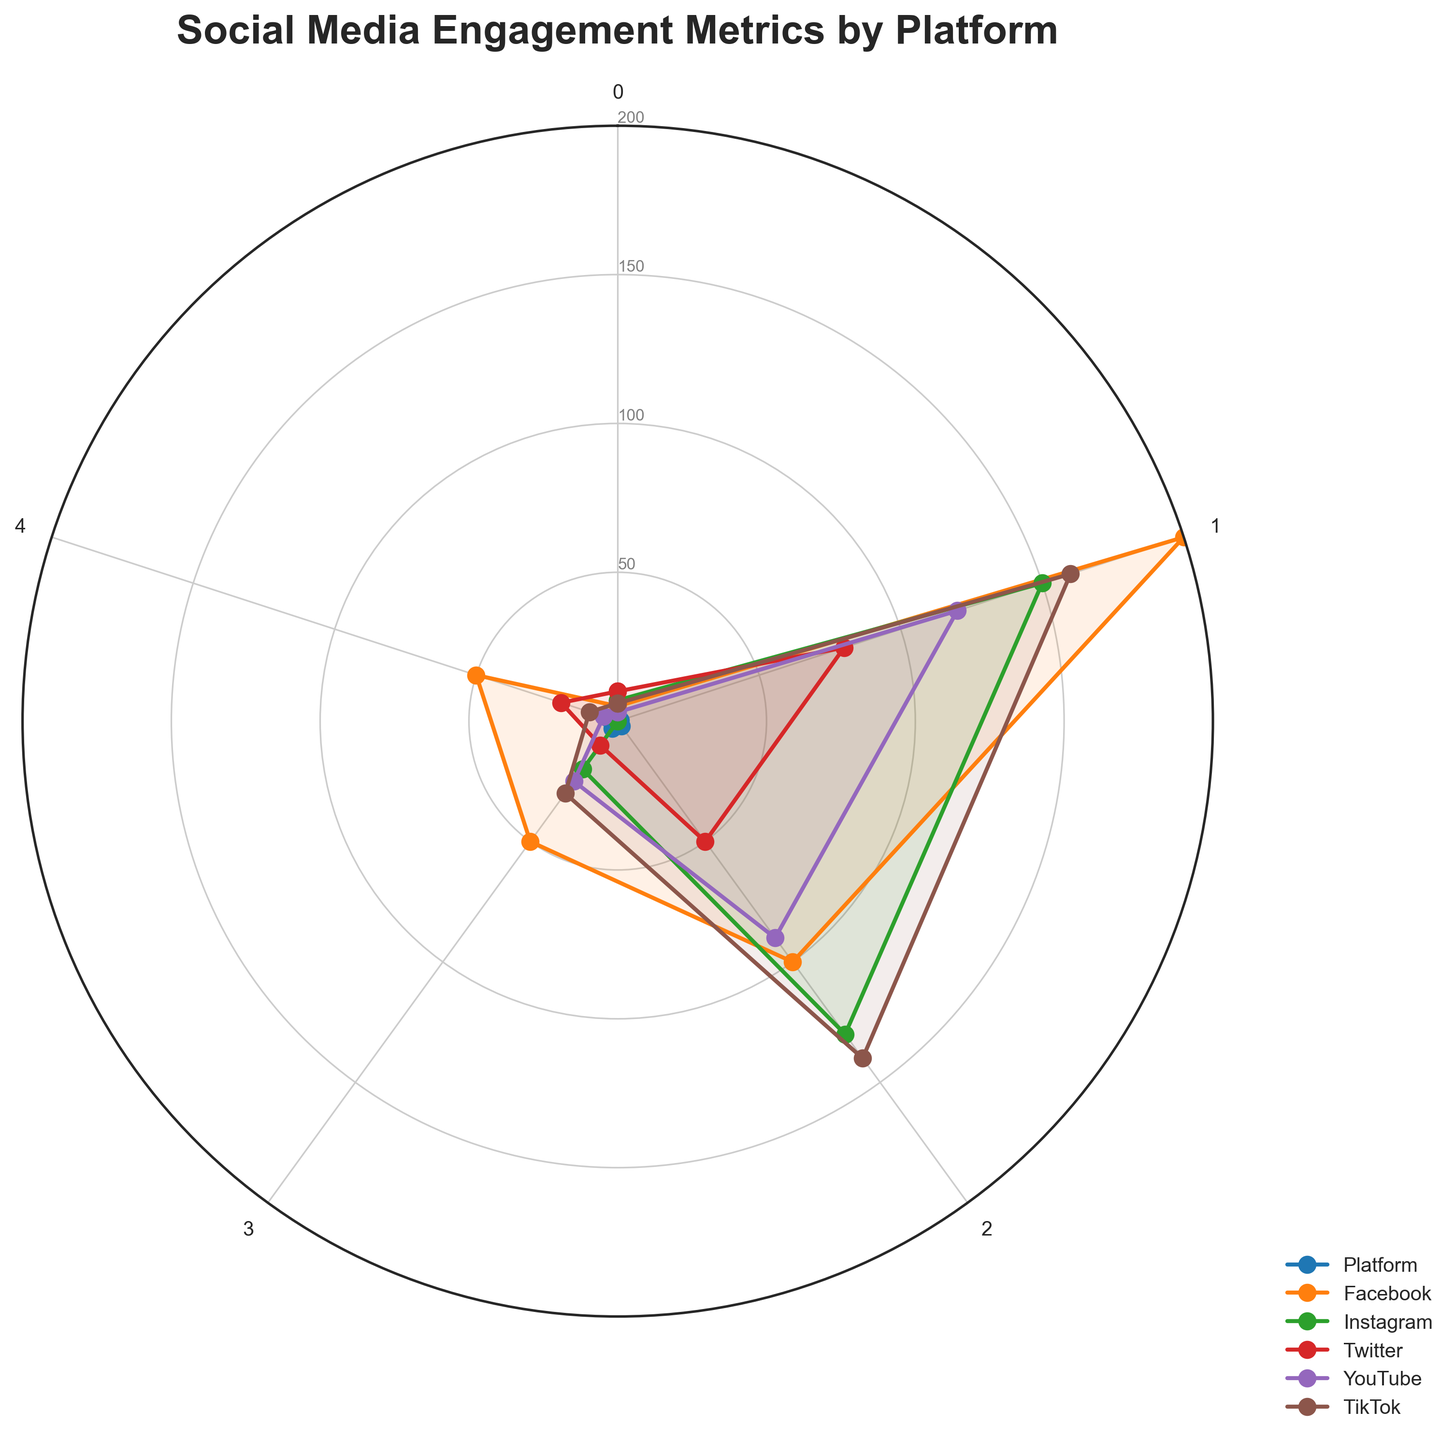What's the title of the chart? The title is usually found at the top of the chart. It should be stated directly as seen.
Answer: Social Media Engagement Metrics by Platform How many platforms are compared in the chart? By counting the distinct labels for the platforms shown around the radar chart, we can see there are five platforms.
Answer: 5 Which platform has the highest 'Posts per Week'? Observing the radar chart, the line that extends the furthest along the 'Posts per Week' axis represents the platform with the highest value in that category.
Answer: Twitter What is the sum of 'Engagements per Post' for Facebook and Instagram? Adding the 'Engagements per Post' values for Facebook (200) and Instagram (150), we get 350.
Answer: 350 How many more 'Average Reactions per Post' does TikTok have than YouTube? Subtracting YouTube's 'Average Reactions per Post' value (90) from TikTok's value (140), we find the difference.
Answer: 50 Which platform has the lowest 'Average Comments per Post'? Observing the 'Average Comments per Post' axis on the radar chart, the platform with the smallest protrusion represents the lowest value.
Answer: Instagram Rank the platforms based on 'Average Shares per Post' from highest to lowest. By comparing the values along the 'Average Shares per Post' axis for all platforms: Facebook (50), YouTube (25), TikTok (30), Instagram (20), and Twitter (10), we determine the order.
Answer: Facebook, TikTok, YouTube, Instagram, Twitter Which metric for YouTube is the highest compared to others? By analyzing YouTube's lines on different axes, the longest line signifies the highest metric for YouTube.
Answer: Engagements per Post What is the average 'Engagements per Post' across all platforms? Adding the 'Engagements per Post' values (200 + 150 + 80 + 120 + 160 = 710) and dividing by the number of platforms (5) gives the average.
Answer: 142 Is there any metric where Facebook and TikTok have equal values? Comparing the values across all metrics, we observe that Facebook and TikTok have the same value in the 'Average Shares per Post' category.
Answer: Yes, 'Average Shares per Post' 